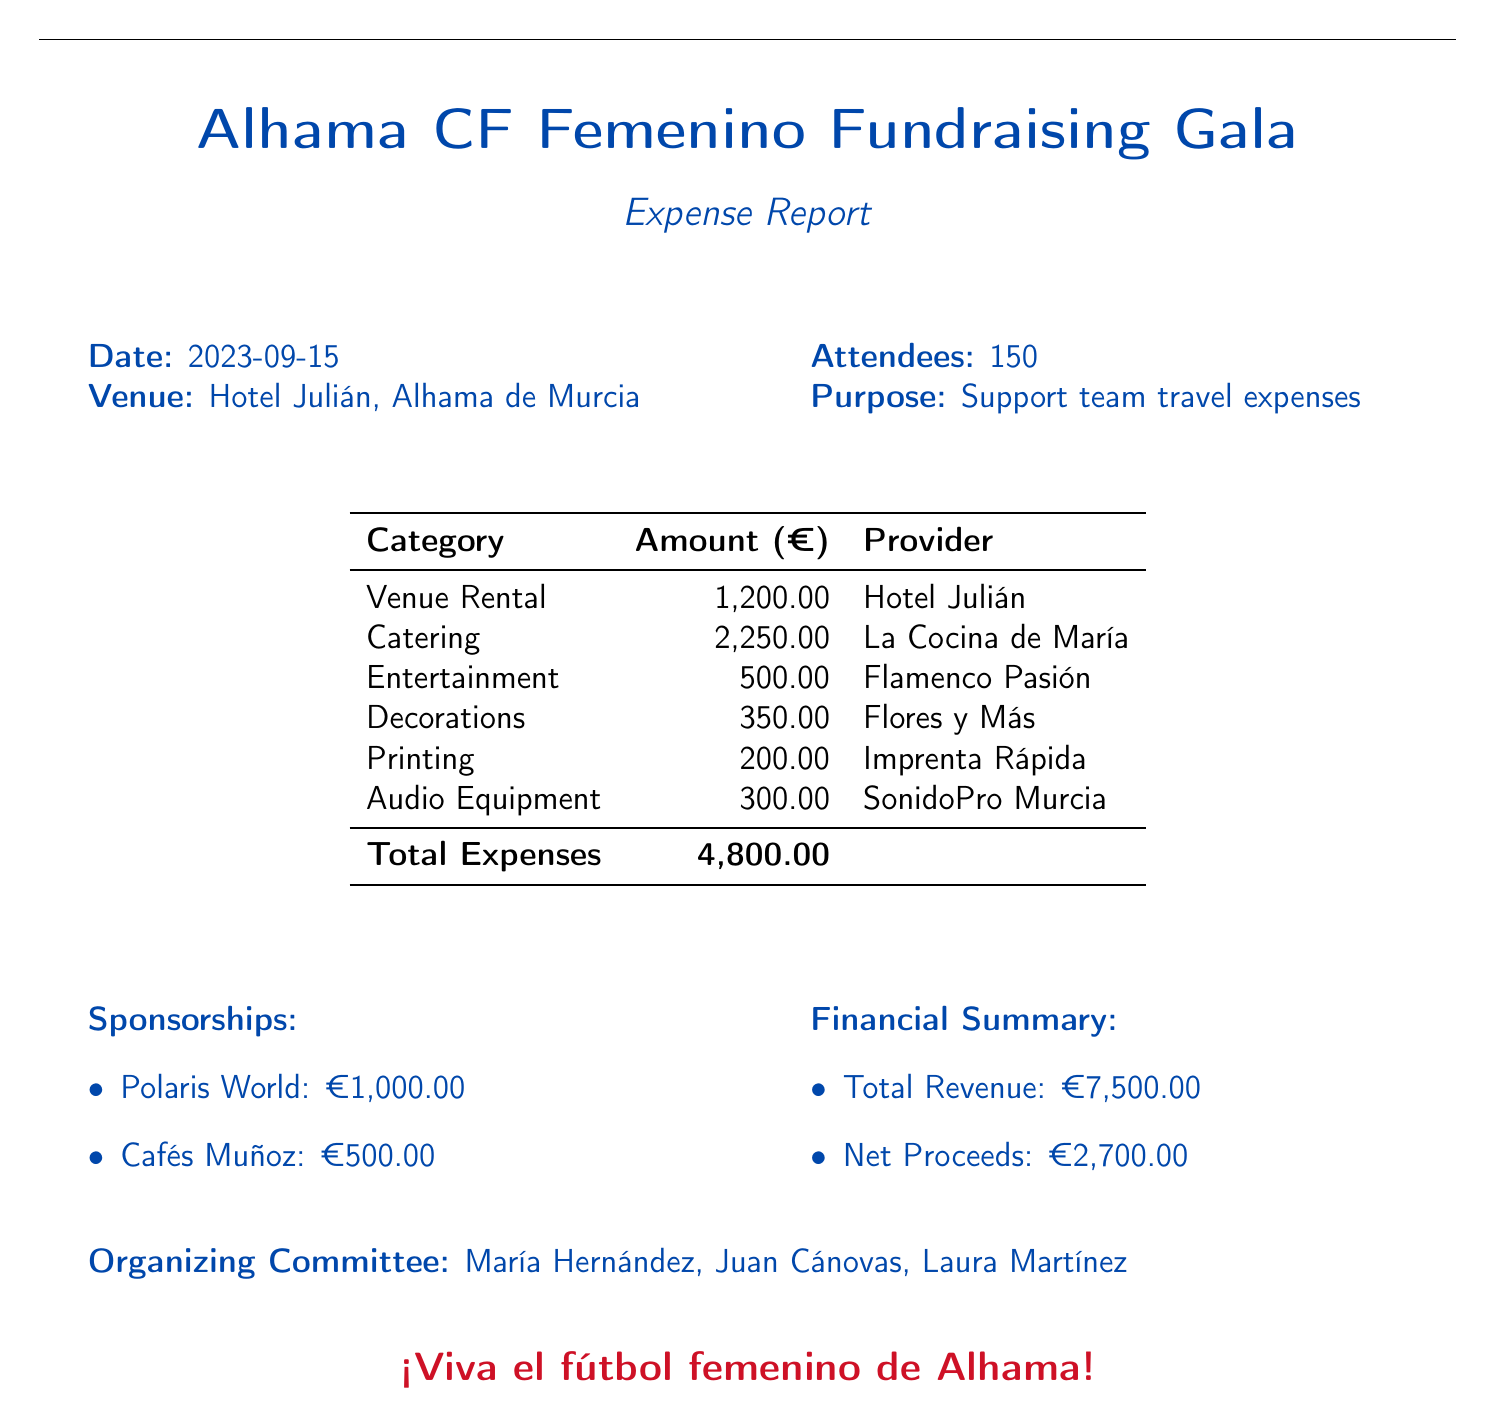what is the date of the event? The date is listed at the beginning of the document under the date section.
Answer: 2023-09-15 what is the venue name? The venue name is mentioned in the venue section of the document.
Answer: Hotel Julián how many attendees were there? The number of attendees is specified in the attendees section of the document.
Answer: 150 what was the total amount of expenses? The total expenses are summarized in the table at the end of the expense breakdown.
Answer: 4,800.00 who are the members of the organizing committee? The organizing committee members are listed at the end of the document.
Answer: María Hernández, Juan Cánovas, Laura Martínez how much did Catering cost? The amount for catering is detailed in the expense table.
Answer: 2,250.00 what is the total revenue from the event? The total revenue is provided in the financial summary section of the document.
Answer: 7,500.00 how much was received from Polaris World? The sponsorship amount from Polaris World is specified in the sponsorships section.
Answer: €1,000.00 what is the net proceeds from the event? The net proceeds are detailed in the financial summary section.
Answer: 2,700.00 